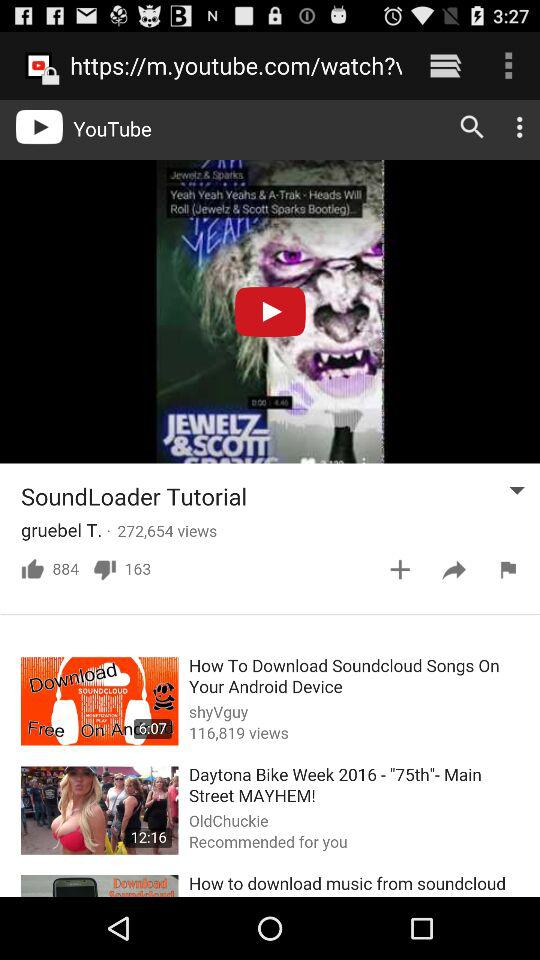On what YouTube channel has the Soundloader tutorial video been uploaded?
Answer the question using a single word or phrase. The video has been uploaded to "gruebel T." 